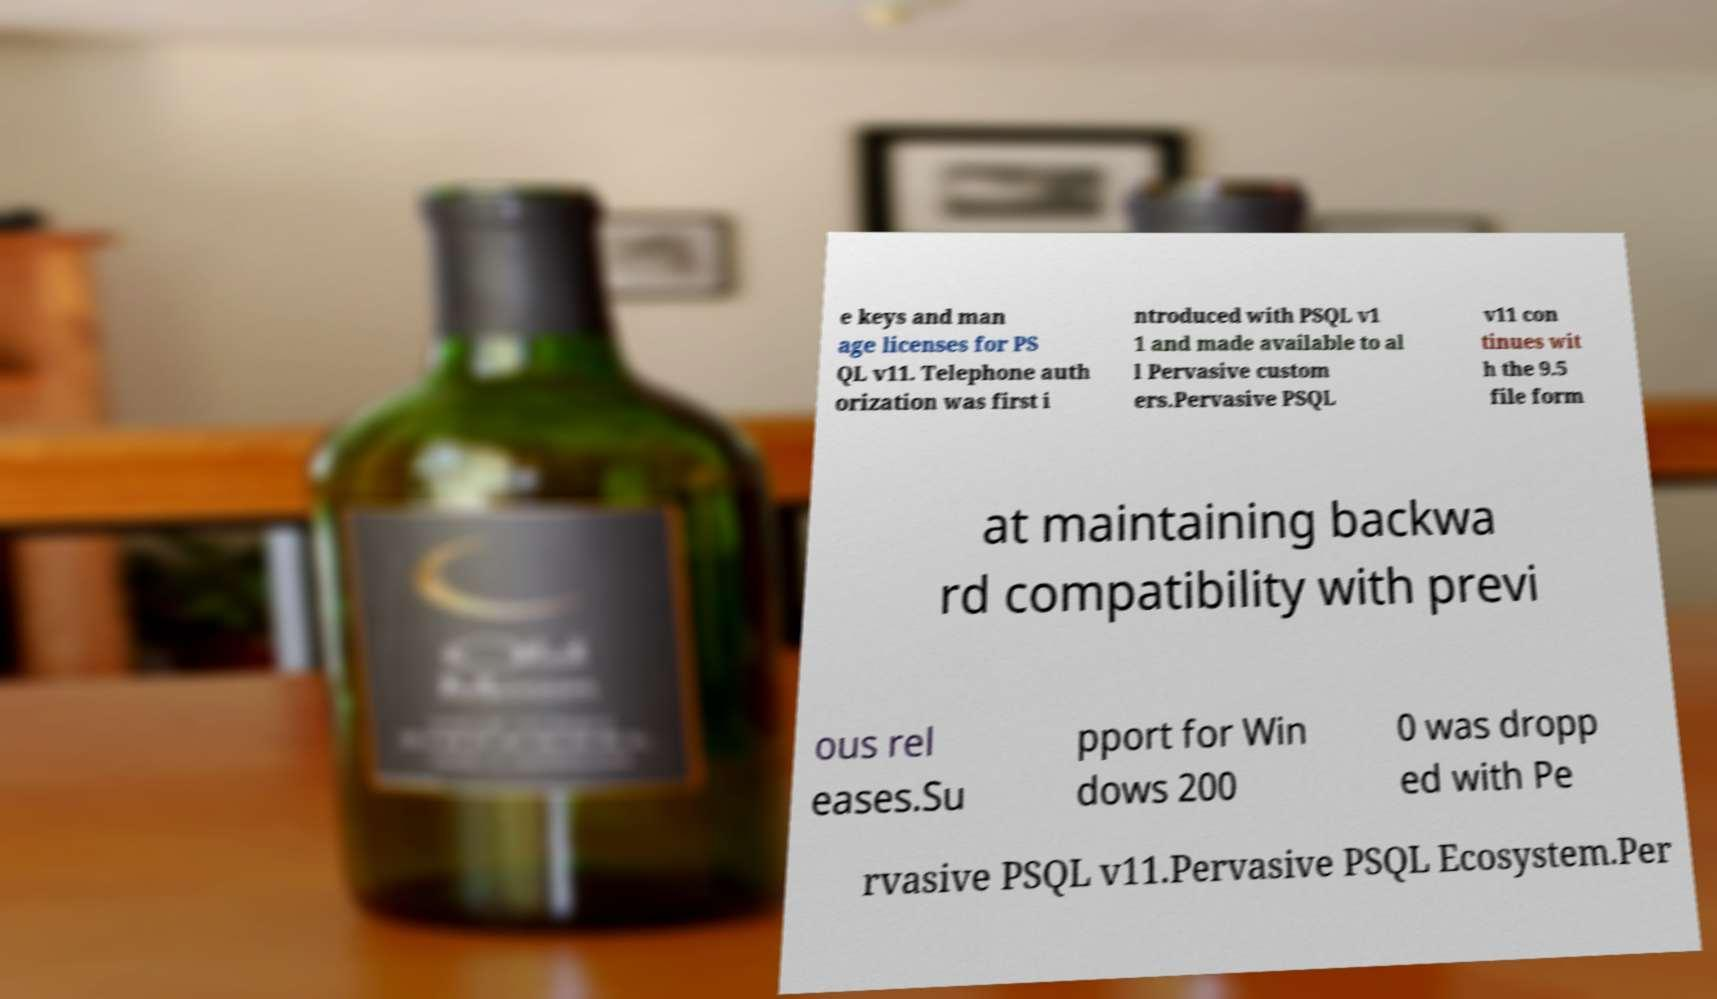What messages or text are displayed in this image? I need them in a readable, typed format. e keys and man age licenses for PS QL v11. Telephone auth orization was first i ntroduced with PSQL v1 1 and made available to al l Pervasive custom ers.Pervasive PSQL v11 con tinues wit h the 9.5 file form at maintaining backwa rd compatibility with previ ous rel eases.Su pport for Win dows 200 0 was dropp ed with Pe rvasive PSQL v11.Pervasive PSQL Ecosystem.Per 